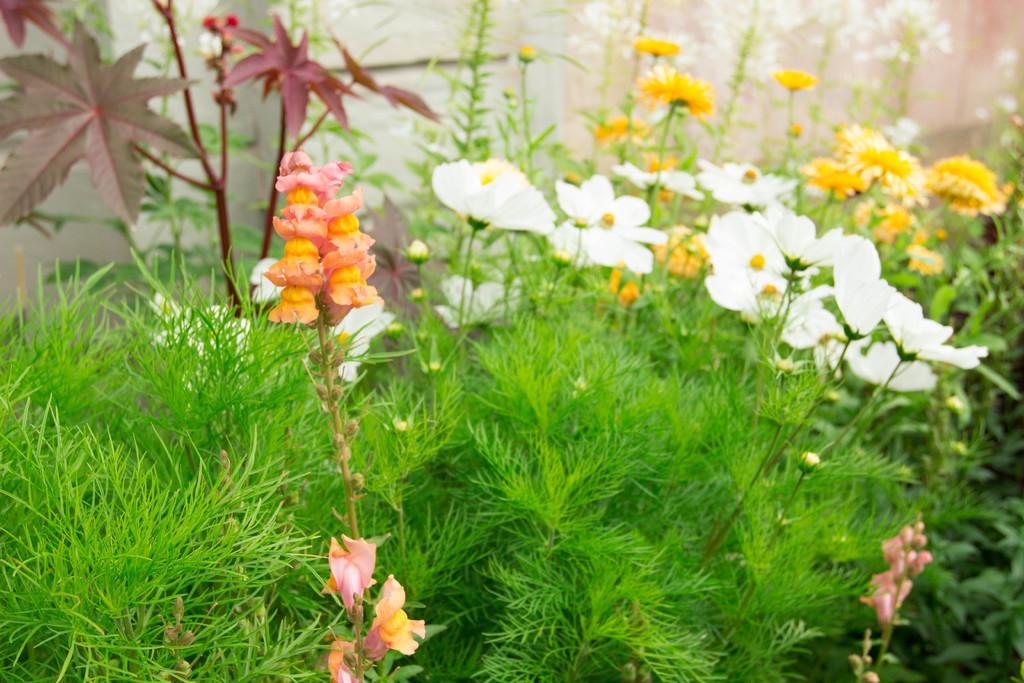Describe this image in one or two sentences. In this image, we can see flowers, leaves, stems, plants. Background we can see a wall. 